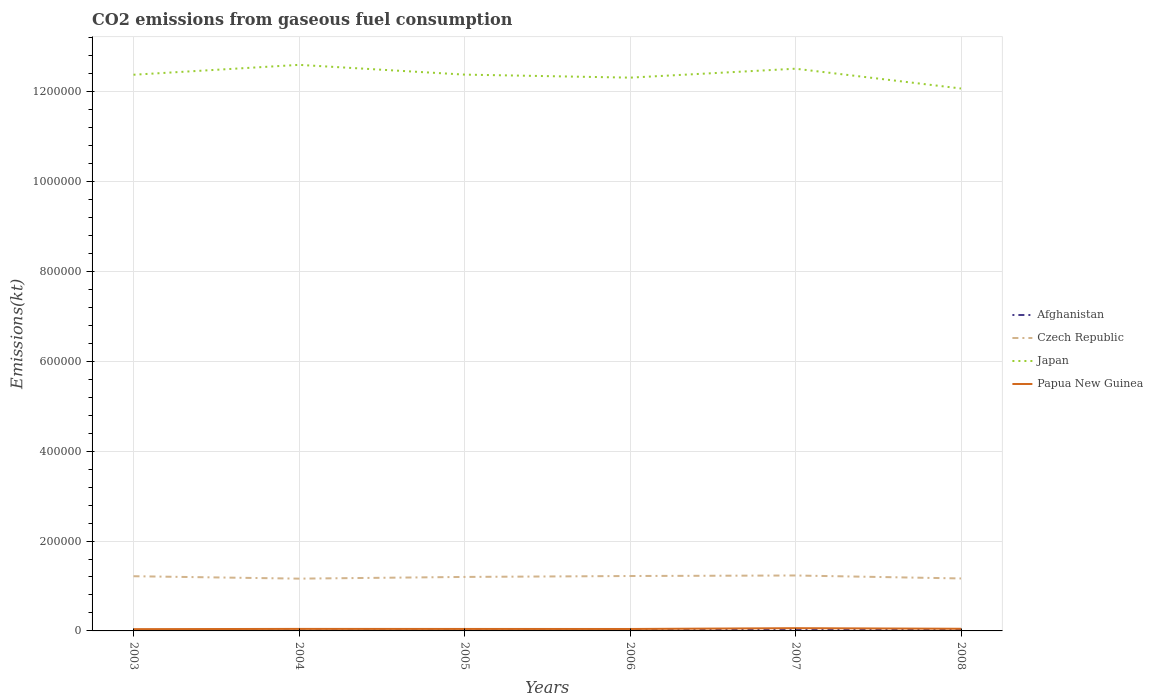Does the line corresponding to Afghanistan intersect with the line corresponding to Czech Republic?
Your response must be concise. No. Across all years, what is the maximum amount of CO2 emitted in Japan?
Provide a short and direct response. 1.21e+06. In which year was the amount of CO2 emitted in Japan maximum?
Offer a very short reply. 2008. What is the total amount of CO2 emitted in Czech Republic in the graph?
Your answer should be compact. 1591.48. What is the difference between the highest and the second highest amount of CO2 emitted in Japan?
Your response must be concise. 5.26e+04. What is the difference between the highest and the lowest amount of CO2 emitted in Afghanistan?
Provide a succinct answer. 2. Is the amount of CO2 emitted in Papua New Guinea strictly greater than the amount of CO2 emitted in Czech Republic over the years?
Give a very brief answer. Yes. How many lines are there?
Provide a succinct answer. 4. Are the values on the major ticks of Y-axis written in scientific E-notation?
Provide a short and direct response. No. Does the graph contain grids?
Your response must be concise. Yes. How many legend labels are there?
Offer a terse response. 4. What is the title of the graph?
Keep it short and to the point. CO2 emissions from gaseous fuel consumption. What is the label or title of the Y-axis?
Provide a succinct answer. Emissions(kt). What is the Emissions(kt) of Afghanistan in 2003?
Ensure brevity in your answer.  1037.76. What is the Emissions(kt) in Czech Republic in 2003?
Your answer should be compact. 1.22e+05. What is the Emissions(kt) in Japan in 2003?
Ensure brevity in your answer.  1.24e+06. What is the Emissions(kt) of Papua New Guinea in 2003?
Offer a terse response. 3945.69. What is the Emissions(kt) in Afghanistan in 2004?
Keep it short and to the point. 957.09. What is the Emissions(kt) of Czech Republic in 2004?
Ensure brevity in your answer.  1.16e+05. What is the Emissions(kt) in Japan in 2004?
Provide a succinct answer. 1.26e+06. What is the Emissions(kt) in Papua New Guinea in 2004?
Your answer should be compact. 4488.41. What is the Emissions(kt) of Afghanistan in 2005?
Keep it short and to the point. 1338.45. What is the Emissions(kt) of Czech Republic in 2005?
Provide a succinct answer. 1.20e+05. What is the Emissions(kt) of Japan in 2005?
Provide a succinct answer. 1.24e+06. What is the Emissions(kt) in Papua New Guinea in 2005?
Your response must be concise. 4385.73. What is the Emissions(kt) in Afghanistan in 2006?
Keep it short and to the point. 1657.48. What is the Emissions(kt) in Czech Republic in 2006?
Your answer should be compact. 1.22e+05. What is the Emissions(kt) in Japan in 2006?
Offer a terse response. 1.23e+06. What is the Emissions(kt) in Papua New Guinea in 2006?
Your answer should be very brief. 4308.73. What is the Emissions(kt) of Afghanistan in 2007?
Offer a terse response. 2280.87. What is the Emissions(kt) of Czech Republic in 2007?
Keep it short and to the point. 1.23e+05. What is the Emissions(kt) in Japan in 2007?
Provide a succinct answer. 1.25e+06. What is the Emissions(kt) in Papua New Guinea in 2007?
Make the answer very short. 6120.22. What is the Emissions(kt) in Afghanistan in 2008?
Keep it short and to the point. 4217.05. What is the Emissions(kt) in Czech Republic in 2008?
Provide a succinct answer. 1.17e+05. What is the Emissions(kt) of Japan in 2008?
Keep it short and to the point. 1.21e+06. What is the Emissions(kt) of Papua New Guinea in 2008?
Provide a short and direct response. 4796.44. Across all years, what is the maximum Emissions(kt) in Afghanistan?
Your answer should be compact. 4217.05. Across all years, what is the maximum Emissions(kt) in Czech Republic?
Make the answer very short. 1.23e+05. Across all years, what is the maximum Emissions(kt) in Japan?
Offer a terse response. 1.26e+06. Across all years, what is the maximum Emissions(kt) of Papua New Guinea?
Make the answer very short. 6120.22. Across all years, what is the minimum Emissions(kt) in Afghanistan?
Ensure brevity in your answer.  957.09. Across all years, what is the minimum Emissions(kt) of Czech Republic?
Make the answer very short. 1.16e+05. Across all years, what is the minimum Emissions(kt) in Japan?
Keep it short and to the point. 1.21e+06. Across all years, what is the minimum Emissions(kt) of Papua New Guinea?
Give a very brief answer. 3945.69. What is the total Emissions(kt) of Afghanistan in the graph?
Keep it short and to the point. 1.15e+04. What is the total Emissions(kt) in Czech Republic in the graph?
Ensure brevity in your answer.  7.20e+05. What is the total Emissions(kt) of Japan in the graph?
Provide a short and direct response. 7.42e+06. What is the total Emissions(kt) of Papua New Guinea in the graph?
Keep it short and to the point. 2.80e+04. What is the difference between the Emissions(kt) of Afghanistan in 2003 and that in 2004?
Give a very brief answer. 80.67. What is the difference between the Emissions(kt) in Czech Republic in 2003 and that in 2004?
Your answer should be compact. 5379.49. What is the difference between the Emissions(kt) of Japan in 2003 and that in 2004?
Offer a terse response. -2.20e+04. What is the difference between the Emissions(kt) in Papua New Guinea in 2003 and that in 2004?
Your answer should be very brief. -542.72. What is the difference between the Emissions(kt) in Afghanistan in 2003 and that in 2005?
Provide a short and direct response. -300.69. What is the difference between the Emissions(kt) in Czech Republic in 2003 and that in 2005?
Your response must be concise. 1591.48. What is the difference between the Emissions(kt) of Japan in 2003 and that in 2005?
Ensure brevity in your answer.  -278.69. What is the difference between the Emissions(kt) of Papua New Guinea in 2003 and that in 2005?
Make the answer very short. -440.04. What is the difference between the Emissions(kt) in Afghanistan in 2003 and that in 2006?
Give a very brief answer. -619.72. What is the difference between the Emissions(kt) in Czech Republic in 2003 and that in 2006?
Your response must be concise. -462.04. What is the difference between the Emissions(kt) in Japan in 2003 and that in 2006?
Provide a succinct answer. 6446.59. What is the difference between the Emissions(kt) of Papua New Guinea in 2003 and that in 2006?
Give a very brief answer. -363.03. What is the difference between the Emissions(kt) in Afghanistan in 2003 and that in 2007?
Provide a succinct answer. -1243.11. What is the difference between the Emissions(kt) in Czech Republic in 2003 and that in 2007?
Provide a succinct answer. -1620.81. What is the difference between the Emissions(kt) in Japan in 2003 and that in 2007?
Make the answer very short. -1.34e+04. What is the difference between the Emissions(kt) in Papua New Guinea in 2003 and that in 2007?
Your response must be concise. -2174.53. What is the difference between the Emissions(kt) of Afghanistan in 2003 and that in 2008?
Offer a very short reply. -3179.29. What is the difference between the Emissions(kt) in Czech Republic in 2003 and that in 2008?
Provide a succinct answer. 4976.12. What is the difference between the Emissions(kt) in Japan in 2003 and that in 2008?
Offer a very short reply. 3.06e+04. What is the difference between the Emissions(kt) of Papua New Guinea in 2003 and that in 2008?
Your answer should be very brief. -850.74. What is the difference between the Emissions(kt) of Afghanistan in 2004 and that in 2005?
Your response must be concise. -381.37. What is the difference between the Emissions(kt) in Czech Republic in 2004 and that in 2005?
Your answer should be very brief. -3788.01. What is the difference between the Emissions(kt) of Japan in 2004 and that in 2005?
Offer a very short reply. 2.17e+04. What is the difference between the Emissions(kt) in Papua New Guinea in 2004 and that in 2005?
Give a very brief answer. 102.68. What is the difference between the Emissions(kt) of Afghanistan in 2004 and that in 2006?
Offer a terse response. -700.4. What is the difference between the Emissions(kt) of Czech Republic in 2004 and that in 2006?
Provide a short and direct response. -5841.53. What is the difference between the Emissions(kt) in Japan in 2004 and that in 2006?
Ensure brevity in your answer.  2.84e+04. What is the difference between the Emissions(kt) of Papua New Guinea in 2004 and that in 2006?
Ensure brevity in your answer.  179.68. What is the difference between the Emissions(kt) of Afghanistan in 2004 and that in 2007?
Offer a terse response. -1323.79. What is the difference between the Emissions(kt) of Czech Republic in 2004 and that in 2007?
Offer a terse response. -7000.3. What is the difference between the Emissions(kt) of Japan in 2004 and that in 2007?
Make the answer very short. 8569.78. What is the difference between the Emissions(kt) of Papua New Guinea in 2004 and that in 2007?
Ensure brevity in your answer.  -1631.82. What is the difference between the Emissions(kt) of Afghanistan in 2004 and that in 2008?
Provide a short and direct response. -3259.96. What is the difference between the Emissions(kt) of Czech Republic in 2004 and that in 2008?
Give a very brief answer. -403.37. What is the difference between the Emissions(kt) of Japan in 2004 and that in 2008?
Keep it short and to the point. 5.26e+04. What is the difference between the Emissions(kt) in Papua New Guinea in 2004 and that in 2008?
Your response must be concise. -308.03. What is the difference between the Emissions(kt) of Afghanistan in 2005 and that in 2006?
Make the answer very short. -319.03. What is the difference between the Emissions(kt) of Czech Republic in 2005 and that in 2006?
Provide a succinct answer. -2053.52. What is the difference between the Emissions(kt) of Japan in 2005 and that in 2006?
Keep it short and to the point. 6725.28. What is the difference between the Emissions(kt) of Papua New Guinea in 2005 and that in 2006?
Offer a very short reply. 77.01. What is the difference between the Emissions(kt) in Afghanistan in 2005 and that in 2007?
Provide a short and direct response. -942.42. What is the difference between the Emissions(kt) in Czech Republic in 2005 and that in 2007?
Give a very brief answer. -3212.29. What is the difference between the Emissions(kt) in Japan in 2005 and that in 2007?
Ensure brevity in your answer.  -1.31e+04. What is the difference between the Emissions(kt) in Papua New Guinea in 2005 and that in 2007?
Offer a very short reply. -1734.49. What is the difference between the Emissions(kt) in Afghanistan in 2005 and that in 2008?
Offer a very short reply. -2878.59. What is the difference between the Emissions(kt) in Czech Republic in 2005 and that in 2008?
Offer a terse response. 3384.64. What is the difference between the Emissions(kt) in Japan in 2005 and that in 2008?
Your answer should be very brief. 3.09e+04. What is the difference between the Emissions(kt) of Papua New Guinea in 2005 and that in 2008?
Provide a succinct answer. -410.7. What is the difference between the Emissions(kt) of Afghanistan in 2006 and that in 2007?
Make the answer very short. -623.39. What is the difference between the Emissions(kt) in Czech Republic in 2006 and that in 2007?
Make the answer very short. -1158.77. What is the difference between the Emissions(kt) in Japan in 2006 and that in 2007?
Give a very brief answer. -1.99e+04. What is the difference between the Emissions(kt) in Papua New Guinea in 2006 and that in 2007?
Offer a very short reply. -1811.5. What is the difference between the Emissions(kt) in Afghanistan in 2006 and that in 2008?
Give a very brief answer. -2559.57. What is the difference between the Emissions(kt) of Czech Republic in 2006 and that in 2008?
Offer a very short reply. 5438.16. What is the difference between the Emissions(kt) in Japan in 2006 and that in 2008?
Give a very brief answer. 2.42e+04. What is the difference between the Emissions(kt) in Papua New Guinea in 2006 and that in 2008?
Your answer should be compact. -487.71. What is the difference between the Emissions(kt) of Afghanistan in 2007 and that in 2008?
Offer a very short reply. -1936.18. What is the difference between the Emissions(kt) of Czech Republic in 2007 and that in 2008?
Offer a terse response. 6596.93. What is the difference between the Emissions(kt) in Japan in 2007 and that in 2008?
Make the answer very short. 4.40e+04. What is the difference between the Emissions(kt) of Papua New Guinea in 2007 and that in 2008?
Keep it short and to the point. 1323.79. What is the difference between the Emissions(kt) in Afghanistan in 2003 and the Emissions(kt) in Czech Republic in 2004?
Offer a terse response. -1.15e+05. What is the difference between the Emissions(kt) of Afghanistan in 2003 and the Emissions(kt) of Japan in 2004?
Provide a short and direct response. -1.26e+06. What is the difference between the Emissions(kt) in Afghanistan in 2003 and the Emissions(kt) in Papua New Guinea in 2004?
Provide a succinct answer. -3450.65. What is the difference between the Emissions(kt) in Czech Republic in 2003 and the Emissions(kt) in Japan in 2004?
Make the answer very short. -1.14e+06. What is the difference between the Emissions(kt) in Czech Republic in 2003 and the Emissions(kt) in Papua New Guinea in 2004?
Keep it short and to the point. 1.17e+05. What is the difference between the Emissions(kt) of Japan in 2003 and the Emissions(kt) of Papua New Guinea in 2004?
Provide a succinct answer. 1.23e+06. What is the difference between the Emissions(kt) in Afghanistan in 2003 and the Emissions(kt) in Czech Republic in 2005?
Make the answer very short. -1.19e+05. What is the difference between the Emissions(kt) in Afghanistan in 2003 and the Emissions(kt) in Japan in 2005?
Your answer should be compact. -1.24e+06. What is the difference between the Emissions(kt) in Afghanistan in 2003 and the Emissions(kt) in Papua New Guinea in 2005?
Keep it short and to the point. -3347.97. What is the difference between the Emissions(kt) in Czech Republic in 2003 and the Emissions(kt) in Japan in 2005?
Ensure brevity in your answer.  -1.12e+06. What is the difference between the Emissions(kt) of Czech Republic in 2003 and the Emissions(kt) of Papua New Guinea in 2005?
Offer a terse response. 1.17e+05. What is the difference between the Emissions(kt) in Japan in 2003 and the Emissions(kt) in Papua New Guinea in 2005?
Offer a very short reply. 1.23e+06. What is the difference between the Emissions(kt) in Afghanistan in 2003 and the Emissions(kt) in Czech Republic in 2006?
Your answer should be compact. -1.21e+05. What is the difference between the Emissions(kt) in Afghanistan in 2003 and the Emissions(kt) in Japan in 2006?
Make the answer very short. -1.23e+06. What is the difference between the Emissions(kt) in Afghanistan in 2003 and the Emissions(kt) in Papua New Guinea in 2006?
Keep it short and to the point. -3270.96. What is the difference between the Emissions(kt) of Czech Republic in 2003 and the Emissions(kt) of Japan in 2006?
Keep it short and to the point. -1.11e+06. What is the difference between the Emissions(kt) in Czech Republic in 2003 and the Emissions(kt) in Papua New Guinea in 2006?
Provide a succinct answer. 1.17e+05. What is the difference between the Emissions(kt) in Japan in 2003 and the Emissions(kt) in Papua New Guinea in 2006?
Your answer should be compact. 1.23e+06. What is the difference between the Emissions(kt) in Afghanistan in 2003 and the Emissions(kt) in Czech Republic in 2007?
Your answer should be compact. -1.22e+05. What is the difference between the Emissions(kt) of Afghanistan in 2003 and the Emissions(kt) of Japan in 2007?
Offer a terse response. -1.25e+06. What is the difference between the Emissions(kt) in Afghanistan in 2003 and the Emissions(kt) in Papua New Guinea in 2007?
Offer a terse response. -5082.46. What is the difference between the Emissions(kt) in Czech Republic in 2003 and the Emissions(kt) in Japan in 2007?
Provide a succinct answer. -1.13e+06. What is the difference between the Emissions(kt) of Czech Republic in 2003 and the Emissions(kt) of Papua New Guinea in 2007?
Make the answer very short. 1.16e+05. What is the difference between the Emissions(kt) of Japan in 2003 and the Emissions(kt) of Papua New Guinea in 2007?
Your response must be concise. 1.23e+06. What is the difference between the Emissions(kt) of Afghanistan in 2003 and the Emissions(kt) of Czech Republic in 2008?
Keep it short and to the point. -1.16e+05. What is the difference between the Emissions(kt) of Afghanistan in 2003 and the Emissions(kt) of Japan in 2008?
Provide a short and direct response. -1.21e+06. What is the difference between the Emissions(kt) in Afghanistan in 2003 and the Emissions(kt) in Papua New Guinea in 2008?
Offer a very short reply. -3758.68. What is the difference between the Emissions(kt) in Czech Republic in 2003 and the Emissions(kt) in Japan in 2008?
Provide a short and direct response. -1.09e+06. What is the difference between the Emissions(kt) in Czech Republic in 2003 and the Emissions(kt) in Papua New Guinea in 2008?
Provide a short and direct response. 1.17e+05. What is the difference between the Emissions(kt) of Japan in 2003 and the Emissions(kt) of Papua New Guinea in 2008?
Provide a succinct answer. 1.23e+06. What is the difference between the Emissions(kt) in Afghanistan in 2004 and the Emissions(kt) in Czech Republic in 2005?
Keep it short and to the point. -1.19e+05. What is the difference between the Emissions(kt) of Afghanistan in 2004 and the Emissions(kt) of Japan in 2005?
Offer a terse response. -1.24e+06. What is the difference between the Emissions(kt) in Afghanistan in 2004 and the Emissions(kt) in Papua New Guinea in 2005?
Your response must be concise. -3428.64. What is the difference between the Emissions(kt) of Czech Republic in 2004 and the Emissions(kt) of Japan in 2005?
Ensure brevity in your answer.  -1.12e+06. What is the difference between the Emissions(kt) of Czech Republic in 2004 and the Emissions(kt) of Papua New Guinea in 2005?
Ensure brevity in your answer.  1.12e+05. What is the difference between the Emissions(kt) in Japan in 2004 and the Emissions(kt) in Papua New Guinea in 2005?
Your answer should be compact. 1.25e+06. What is the difference between the Emissions(kt) of Afghanistan in 2004 and the Emissions(kt) of Czech Republic in 2006?
Offer a terse response. -1.21e+05. What is the difference between the Emissions(kt) of Afghanistan in 2004 and the Emissions(kt) of Japan in 2006?
Make the answer very short. -1.23e+06. What is the difference between the Emissions(kt) in Afghanistan in 2004 and the Emissions(kt) in Papua New Guinea in 2006?
Offer a very short reply. -3351.64. What is the difference between the Emissions(kt) in Czech Republic in 2004 and the Emissions(kt) in Japan in 2006?
Keep it short and to the point. -1.11e+06. What is the difference between the Emissions(kt) in Czech Republic in 2004 and the Emissions(kt) in Papua New Guinea in 2006?
Your response must be concise. 1.12e+05. What is the difference between the Emissions(kt) of Japan in 2004 and the Emissions(kt) of Papua New Guinea in 2006?
Offer a terse response. 1.26e+06. What is the difference between the Emissions(kt) of Afghanistan in 2004 and the Emissions(kt) of Czech Republic in 2007?
Provide a short and direct response. -1.22e+05. What is the difference between the Emissions(kt) of Afghanistan in 2004 and the Emissions(kt) of Japan in 2007?
Offer a terse response. -1.25e+06. What is the difference between the Emissions(kt) of Afghanistan in 2004 and the Emissions(kt) of Papua New Guinea in 2007?
Offer a very short reply. -5163.14. What is the difference between the Emissions(kt) in Czech Republic in 2004 and the Emissions(kt) in Japan in 2007?
Offer a very short reply. -1.13e+06. What is the difference between the Emissions(kt) in Czech Republic in 2004 and the Emissions(kt) in Papua New Guinea in 2007?
Keep it short and to the point. 1.10e+05. What is the difference between the Emissions(kt) of Japan in 2004 and the Emissions(kt) of Papua New Guinea in 2007?
Offer a terse response. 1.25e+06. What is the difference between the Emissions(kt) of Afghanistan in 2004 and the Emissions(kt) of Czech Republic in 2008?
Provide a short and direct response. -1.16e+05. What is the difference between the Emissions(kt) in Afghanistan in 2004 and the Emissions(kt) in Japan in 2008?
Offer a terse response. -1.21e+06. What is the difference between the Emissions(kt) in Afghanistan in 2004 and the Emissions(kt) in Papua New Guinea in 2008?
Give a very brief answer. -3839.35. What is the difference between the Emissions(kt) of Czech Republic in 2004 and the Emissions(kt) of Japan in 2008?
Your answer should be very brief. -1.09e+06. What is the difference between the Emissions(kt) in Czech Republic in 2004 and the Emissions(kt) in Papua New Guinea in 2008?
Your answer should be compact. 1.12e+05. What is the difference between the Emissions(kt) of Japan in 2004 and the Emissions(kt) of Papua New Guinea in 2008?
Offer a very short reply. 1.25e+06. What is the difference between the Emissions(kt) of Afghanistan in 2005 and the Emissions(kt) of Czech Republic in 2006?
Your answer should be very brief. -1.21e+05. What is the difference between the Emissions(kt) in Afghanistan in 2005 and the Emissions(kt) in Japan in 2006?
Your response must be concise. -1.23e+06. What is the difference between the Emissions(kt) in Afghanistan in 2005 and the Emissions(kt) in Papua New Guinea in 2006?
Give a very brief answer. -2970.27. What is the difference between the Emissions(kt) of Czech Republic in 2005 and the Emissions(kt) of Japan in 2006?
Ensure brevity in your answer.  -1.11e+06. What is the difference between the Emissions(kt) of Czech Republic in 2005 and the Emissions(kt) of Papua New Guinea in 2006?
Provide a short and direct response. 1.16e+05. What is the difference between the Emissions(kt) of Japan in 2005 and the Emissions(kt) of Papua New Guinea in 2006?
Offer a very short reply. 1.23e+06. What is the difference between the Emissions(kt) in Afghanistan in 2005 and the Emissions(kt) in Czech Republic in 2007?
Provide a succinct answer. -1.22e+05. What is the difference between the Emissions(kt) in Afghanistan in 2005 and the Emissions(kt) in Japan in 2007?
Provide a succinct answer. -1.25e+06. What is the difference between the Emissions(kt) of Afghanistan in 2005 and the Emissions(kt) of Papua New Guinea in 2007?
Make the answer very short. -4781.77. What is the difference between the Emissions(kt) in Czech Republic in 2005 and the Emissions(kt) in Japan in 2007?
Make the answer very short. -1.13e+06. What is the difference between the Emissions(kt) of Czech Republic in 2005 and the Emissions(kt) of Papua New Guinea in 2007?
Provide a succinct answer. 1.14e+05. What is the difference between the Emissions(kt) in Japan in 2005 and the Emissions(kt) in Papua New Guinea in 2007?
Provide a short and direct response. 1.23e+06. What is the difference between the Emissions(kt) in Afghanistan in 2005 and the Emissions(kt) in Czech Republic in 2008?
Your response must be concise. -1.15e+05. What is the difference between the Emissions(kt) in Afghanistan in 2005 and the Emissions(kt) in Japan in 2008?
Provide a succinct answer. -1.21e+06. What is the difference between the Emissions(kt) of Afghanistan in 2005 and the Emissions(kt) of Papua New Guinea in 2008?
Ensure brevity in your answer.  -3457.98. What is the difference between the Emissions(kt) in Czech Republic in 2005 and the Emissions(kt) in Japan in 2008?
Make the answer very short. -1.09e+06. What is the difference between the Emissions(kt) of Czech Republic in 2005 and the Emissions(kt) of Papua New Guinea in 2008?
Provide a succinct answer. 1.15e+05. What is the difference between the Emissions(kt) in Japan in 2005 and the Emissions(kt) in Papua New Guinea in 2008?
Provide a succinct answer. 1.23e+06. What is the difference between the Emissions(kt) of Afghanistan in 2006 and the Emissions(kt) of Czech Republic in 2007?
Your answer should be very brief. -1.22e+05. What is the difference between the Emissions(kt) of Afghanistan in 2006 and the Emissions(kt) of Japan in 2007?
Ensure brevity in your answer.  -1.25e+06. What is the difference between the Emissions(kt) of Afghanistan in 2006 and the Emissions(kt) of Papua New Guinea in 2007?
Ensure brevity in your answer.  -4462.74. What is the difference between the Emissions(kt) in Czech Republic in 2006 and the Emissions(kt) in Japan in 2007?
Offer a very short reply. -1.13e+06. What is the difference between the Emissions(kt) in Czech Republic in 2006 and the Emissions(kt) in Papua New Guinea in 2007?
Your answer should be compact. 1.16e+05. What is the difference between the Emissions(kt) of Japan in 2006 and the Emissions(kt) of Papua New Guinea in 2007?
Your answer should be very brief. 1.22e+06. What is the difference between the Emissions(kt) of Afghanistan in 2006 and the Emissions(kt) of Czech Republic in 2008?
Provide a succinct answer. -1.15e+05. What is the difference between the Emissions(kt) of Afghanistan in 2006 and the Emissions(kt) of Japan in 2008?
Your answer should be very brief. -1.21e+06. What is the difference between the Emissions(kt) in Afghanistan in 2006 and the Emissions(kt) in Papua New Guinea in 2008?
Make the answer very short. -3138.95. What is the difference between the Emissions(kt) of Czech Republic in 2006 and the Emissions(kt) of Japan in 2008?
Your answer should be compact. -1.08e+06. What is the difference between the Emissions(kt) in Czech Republic in 2006 and the Emissions(kt) in Papua New Guinea in 2008?
Offer a very short reply. 1.17e+05. What is the difference between the Emissions(kt) in Japan in 2006 and the Emissions(kt) in Papua New Guinea in 2008?
Your answer should be compact. 1.23e+06. What is the difference between the Emissions(kt) of Afghanistan in 2007 and the Emissions(kt) of Czech Republic in 2008?
Ensure brevity in your answer.  -1.14e+05. What is the difference between the Emissions(kt) in Afghanistan in 2007 and the Emissions(kt) in Japan in 2008?
Give a very brief answer. -1.20e+06. What is the difference between the Emissions(kt) in Afghanistan in 2007 and the Emissions(kt) in Papua New Guinea in 2008?
Make the answer very short. -2515.56. What is the difference between the Emissions(kt) of Czech Republic in 2007 and the Emissions(kt) of Japan in 2008?
Provide a succinct answer. -1.08e+06. What is the difference between the Emissions(kt) in Czech Republic in 2007 and the Emissions(kt) in Papua New Guinea in 2008?
Make the answer very short. 1.19e+05. What is the difference between the Emissions(kt) of Japan in 2007 and the Emissions(kt) of Papua New Guinea in 2008?
Your answer should be very brief. 1.25e+06. What is the average Emissions(kt) in Afghanistan per year?
Keep it short and to the point. 1914.79. What is the average Emissions(kt) in Czech Republic per year?
Your answer should be very brief. 1.20e+05. What is the average Emissions(kt) in Japan per year?
Your response must be concise. 1.24e+06. What is the average Emissions(kt) of Papua New Guinea per year?
Offer a very short reply. 4674.2. In the year 2003, what is the difference between the Emissions(kt) in Afghanistan and Emissions(kt) in Czech Republic?
Keep it short and to the point. -1.21e+05. In the year 2003, what is the difference between the Emissions(kt) of Afghanistan and Emissions(kt) of Japan?
Make the answer very short. -1.24e+06. In the year 2003, what is the difference between the Emissions(kt) of Afghanistan and Emissions(kt) of Papua New Guinea?
Keep it short and to the point. -2907.93. In the year 2003, what is the difference between the Emissions(kt) in Czech Republic and Emissions(kt) in Japan?
Give a very brief answer. -1.12e+06. In the year 2003, what is the difference between the Emissions(kt) of Czech Republic and Emissions(kt) of Papua New Guinea?
Provide a succinct answer. 1.18e+05. In the year 2003, what is the difference between the Emissions(kt) of Japan and Emissions(kt) of Papua New Guinea?
Make the answer very short. 1.23e+06. In the year 2004, what is the difference between the Emissions(kt) in Afghanistan and Emissions(kt) in Czech Republic?
Your answer should be very brief. -1.15e+05. In the year 2004, what is the difference between the Emissions(kt) in Afghanistan and Emissions(kt) in Japan?
Offer a very short reply. -1.26e+06. In the year 2004, what is the difference between the Emissions(kt) in Afghanistan and Emissions(kt) in Papua New Guinea?
Make the answer very short. -3531.32. In the year 2004, what is the difference between the Emissions(kt) in Czech Republic and Emissions(kt) in Japan?
Keep it short and to the point. -1.14e+06. In the year 2004, what is the difference between the Emissions(kt) in Czech Republic and Emissions(kt) in Papua New Guinea?
Make the answer very short. 1.12e+05. In the year 2004, what is the difference between the Emissions(kt) in Japan and Emissions(kt) in Papua New Guinea?
Offer a terse response. 1.25e+06. In the year 2005, what is the difference between the Emissions(kt) in Afghanistan and Emissions(kt) in Czech Republic?
Give a very brief answer. -1.19e+05. In the year 2005, what is the difference between the Emissions(kt) of Afghanistan and Emissions(kt) of Japan?
Provide a short and direct response. -1.24e+06. In the year 2005, what is the difference between the Emissions(kt) in Afghanistan and Emissions(kt) in Papua New Guinea?
Your answer should be very brief. -3047.28. In the year 2005, what is the difference between the Emissions(kt) of Czech Republic and Emissions(kt) of Japan?
Offer a terse response. -1.12e+06. In the year 2005, what is the difference between the Emissions(kt) of Czech Republic and Emissions(kt) of Papua New Guinea?
Offer a very short reply. 1.16e+05. In the year 2005, what is the difference between the Emissions(kt) of Japan and Emissions(kt) of Papua New Guinea?
Keep it short and to the point. 1.23e+06. In the year 2006, what is the difference between the Emissions(kt) in Afghanistan and Emissions(kt) in Czech Republic?
Make the answer very short. -1.21e+05. In the year 2006, what is the difference between the Emissions(kt) in Afghanistan and Emissions(kt) in Japan?
Ensure brevity in your answer.  -1.23e+06. In the year 2006, what is the difference between the Emissions(kt) of Afghanistan and Emissions(kt) of Papua New Guinea?
Provide a short and direct response. -2651.24. In the year 2006, what is the difference between the Emissions(kt) of Czech Republic and Emissions(kt) of Japan?
Your answer should be very brief. -1.11e+06. In the year 2006, what is the difference between the Emissions(kt) in Czech Republic and Emissions(kt) in Papua New Guinea?
Offer a very short reply. 1.18e+05. In the year 2006, what is the difference between the Emissions(kt) of Japan and Emissions(kt) of Papua New Guinea?
Provide a short and direct response. 1.23e+06. In the year 2007, what is the difference between the Emissions(kt) in Afghanistan and Emissions(kt) in Czech Republic?
Your answer should be very brief. -1.21e+05. In the year 2007, what is the difference between the Emissions(kt) of Afghanistan and Emissions(kt) of Japan?
Offer a terse response. -1.25e+06. In the year 2007, what is the difference between the Emissions(kt) of Afghanistan and Emissions(kt) of Papua New Guinea?
Make the answer very short. -3839.35. In the year 2007, what is the difference between the Emissions(kt) of Czech Republic and Emissions(kt) of Japan?
Your answer should be compact. -1.13e+06. In the year 2007, what is the difference between the Emissions(kt) of Czech Republic and Emissions(kt) of Papua New Guinea?
Your answer should be compact. 1.17e+05. In the year 2007, what is the difference between the Emissions(kt) of Japan and Emissions(kt) of Papua New Guinea?
Keep it short and to the point. 1.24e+06. In the year 2008, what is the difference between the Emissions(kt) in Afghanistan and Emissions(kt) in Czech Republic?
Give a very brief answer. -1.13e+05. In the year 2008, what is the difference between the Emissions(kt) in Afghanistan and Emissions(kt) in Japan?
Your answer should be compact. -1.20e+06. In the year 2008, what is the difference between the Emissions(kt) in Afghanistan and Emissions(kt) in Papua New Guinea?
Provide a succinct answer. -579.39. In the year 2008, what is the difference between the Emissions(kt) in Czech Republic and Emissions(kt) in Japan?
Provide a succinct answer. -1.09e+06. In the year 2008, what is the difference between the Emissions(kt) in Czech Republic and Emissions(kt) in Papua New Guinea?
Offer a terse response. 1.12e+05. In the year 2008, what is the difference between the Emissions(kt) in Japan and Emissions(kt) in Papua New Guinea?
Offer a very short reply. 1.20e+06. What is the ratio of the Emissions(kt) of Afghanistan in 2003 to that in 2004?
Give a very brief answer. 1.08. What is the ratio of the Emissions(kt) of Czech Republic in 2003 to that in 2004?
Your answer should be very brief. 1.05. What is the ratio of the Emissions(kt) of Japan in 2003 to that in 2004?
Make the answer very short. 0.98. What is the ratio of the Emissions(kt) in Papua New Guinea in 2003 to that in 2004?
Make the answer very short. 0.88. What is the ratio of the Emissions(kt) in Afghanistan in 2003 to that in 2005?
Provide a short and direct response. 0.78. What is the ratio of the Emissions(kt) in Czech Republic in 2003 to that in 2005?
Provide a short and direct response. 1.01. What is the ratio of the Emissions(kt) of Papua New Guinea in 2003 to that in 2005?
Ensure brevity in your answer.  0.9. What is the ratio of the Emissions(kt) of Afghanistan in 2003 to that in 2006?
Your answer should be very brief. 0.63. What is the ratio of the Emissions(kt) in Czech Republic in 2003 to that in 2006?
Your answer should be very brief. 1. What is the ratio of the Emissions(kt) of Papua New Guinea in 2003 to that in 2006?
Offer a very short reply. 0.92. What is the ratio of the Emissions(kt) of Afghanistan in 2003 to that in 2007?
Offer a terse response. 0.46. What is the ratio of the Emissions(kt) of Czech Republic in 2003 to that in 2007?
Your answer should be compact. 0.99. What is the ratio of the Emissions(kt) in Japan in 2003 to that in 2007?
Make the answer very short. 0.99. What is the ratio of the Emissions(kt) in Papua New Guinea in 2003 to that in 2007?
Your answer should be very brief. 0.64. What is the ratio of the Emissions(kt) in Afghanistan in 2003 to that in 2008?
Ensure brevity in your answer.  0.25. What is the ratio of the Emissions(kt) in Czech Republic in 2003 to that in 2008?
Your answer should be very brief. 1.04. What is the ratio of the Emissions(kt) of Japan in 2003 to that in 2008?
Offer a terse response. 1.03. What is the ratio of the Emissions(kt) of Papua New Guinea in 2003 to that in 2008?
Your response must be concise. 0.82. What is the ratio of the Emissions(kt) of Afghanistan in 2004 to that in 2005?
Make the answer very short. 0.72. What is the ratio of the Emissions(kt) of Czech Republic in 2004 to that in 2005?
Your answer should be very brief. 0.97. What is the ratio of the Emissions(kt) in Japan in 2004 to that in 2005?
Give a very brief answer. 1.02. What is the ratio of the Emissions(kt) in Papua New Guinea in 2004 to that in 2005?
Provide a succinct answer. 1.02. What is the ratio of the Emissions(kt) of Afghanistan in 2004 to that in 2006?
Your response must be concise. 0.58. What is the ratio of the Emissions(kt) in Czech Republic in 2004 to that in 2006?
Provide a short and direct response. 0.95. What is the ratio of the Emissions(kt) in Japan in 2004 to that in 2006?
Ensure brevity in your answer.  1.02. What is the ratio of the Emissions(kt) in Papua New Guinea in 2004 to that in 2006?
Provide a succinct answer. 1.04. What is the ratio of the Emissions(kt) of Afghanistan in 2004 to that in 2007?
Make the answer very short. 0.42. What is the ratio of the Emissions(kt) of Czech Republic in 2004 to that in 2007?
Your answer should be very brief. 0.94. What is the ratio of the Emissions(kt) of Japan in 2004 to that in 2007?
Offer a very short reply. 1.01. What is the ratio of the Emissions(kt) in Papua New Guinea in 2004 to that in 2007?
Your answer should be very brief. 0.73. What is the ratio of the Emissions(kt) in Afghanistan in 2004 to that in 2008?
Offer a very short reply. 0.23. What is the ratio of the Emissions(kt) in Czech Republic in 2004 to that in 2008?
Offer a terse response. 1. What is the ratio of the Emissions(kt) in Japan in 2004 to that in 2008?
Give a very brief answer. 1.04. What is the ratio of the Emissions(kt) in Papua New Guinea in 2004 to that in 2008?
Give a very brief answer. 0.94. What is the ratio of the Emissions(kt) in Afghanistan in 2005 to that in 2006?
Provide a short and direct response. 0.81. What is the ratio of the Emissions(kt) in Czech Republic in 2005 to that in 2006?
Offer a terse response. 0.98. What is the ratio of the Emissions(kt) in Papua New Guinea in 2005 to that in 2006?
Provide a succinct answer. 1.02. What is the ratio of the Emissions(kt) in Afghanistan in 2005 to that in 2007?
Keep it short and to the point. 0.59. What is the ratio of the Emissions(kt) of Czech Republic in 2005 to that in 2007?
Ensure brevity in your answer.  0.97. What is the ratio of the Emissions(kt) in Japan in 2005 to that in 2007?
Your answer should be compact. 0.99. What is the ratio of the Emissions(kt) in Papua New Guinea in 2005 to that in 2007?
Make the answer very short. 0.72. What is the ratio of the Emissions(kt) of Afghanistan in 2005 to that in 2008?
Give a very brief answer. 0.32. What is the ratio of the Emissions(kt) of Japan in 2005 to that in 2008?
Ensure brevity in your answer.  1.03. What is the ratio of the Emissions(kt) in Papua New Guinea in 2005 to that in 2008?
Ensure brevity in your answer.  0.91. What is the ratio of the Emissions(kt) in Afghanistan in 2006 to that in 2007?
Ensure brevity in your answer.  0.73. What is the ratio of the Emissions(kt) in Czech Republic in 2006 to that in 2007?
Offer a very short reply. 0.99. What is the ratio of the Emissions(kt) in Japan in 2006 to that in 2007?
Give a very brief answer. 0.98. What is the ratio of the Emissions(kt) of Papua New Guinea in 2006 to that in 2007?
Offer a terse response. 0.7. What is the ratio of the Emissions(kt) in Afghanistan in 2006 to that in 2008?
Ensure brevity in your answer.  0.39. What is the ratio of the Emissions(kt) in Czech Republic in 2006 to that in 2008?
Give a very brief answer. 1.05. What is the ratio of the Emissions(kt) of Japan in 2006 to that in 2008?
Make the answer very short. 1.02. What is the ratio of the Emissions(kt) of Papua New Guinea in 2006 to that in 2008?
Make the answer very short. 0.9. What is the ratio of the Emissions(kt) in Afghanistan in 2007 to that in 2008?
Your response must be concise. 0.54. What is the ratio of the Emissions(kt) in Czech Republic in 2007 to that in 2008?
Offer a very short reply. 1.06. What is the ratio of the Emissions(kt) of Japan in 2007 to that in 2008?
Make the answer very short. 1.04. What is the ratio of the Emissions(kt) in Papua New Guinea in 2007 to that in 2008?
Offer a terse response. 1.28. What is the difference between the highest and the second highest Emissions(kt) of Afghanistan?
Your answer should be very brief. 1936.18. What is the difference between the highest and the second highest Emissions(kt) of Czech Republic?
Your answer should be very brief. 1158.77. What is the difference between the highest and the second highest Emissions(kt) in Japan?
Your answer should be very brief. 8569.78. What is the difference between the highest and the second highest Emissions(kt) in Papua New Guinea?
Your answer should be very brief. 1323.79. What is the difference between the highest and the lowest Emissions(kt) of Afghanistan?
Provide a succinct answer. 3259.96. What is the difference between the highest and the lowest Emissions(kt) in Czech Republic?
Provide a succinct answer. 7000.3. What is the difference between the highest and the lowest Emissions(kt) in Japan?
Offer a very short reply. 5.26e+04. What is the difference between the highest and the lowest Emissions(kt) in Papua New Guinea?
Offer a terse response. 2174.53. 